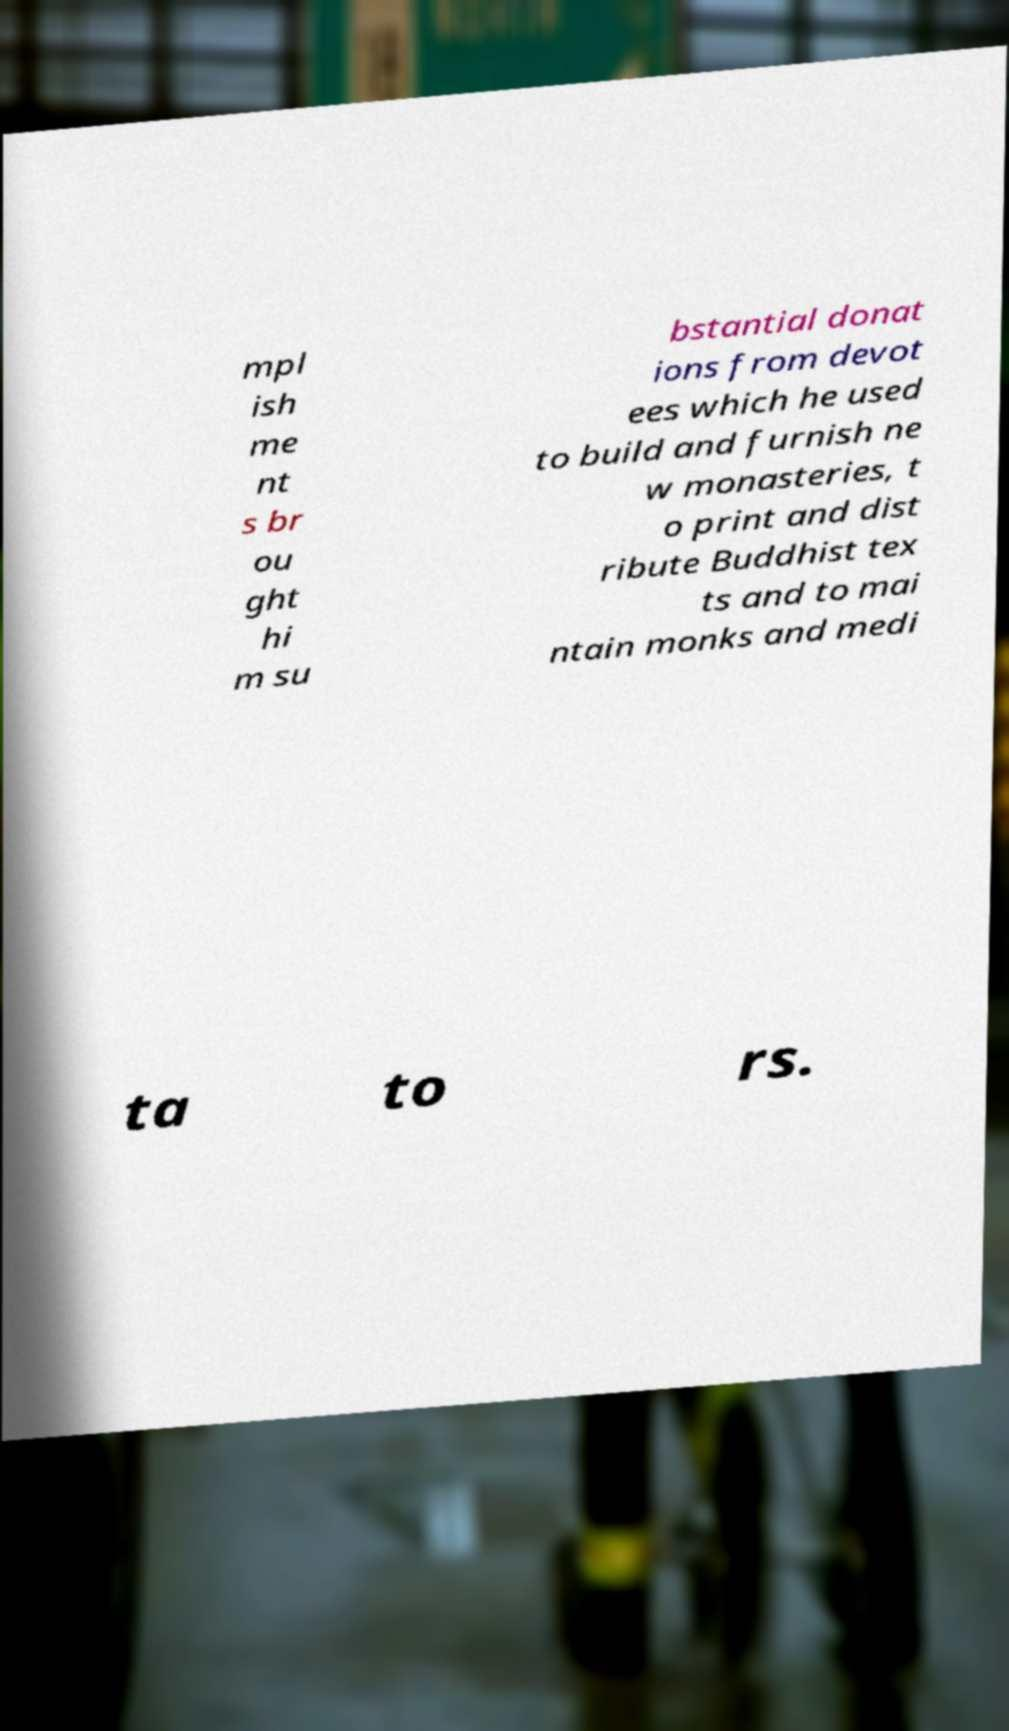Can you read and provide the text displayed in the image?This photo seems to have some interesting text. Can you extract and type it out for me? mpl ish me nt s br ou ght hi m su bstantial donat ions from devot ees which he used to build and furnish ne w monasteries, t o print and dist ribute Buddhist tex ts and to mai ntain monks and medi ta to rs. 